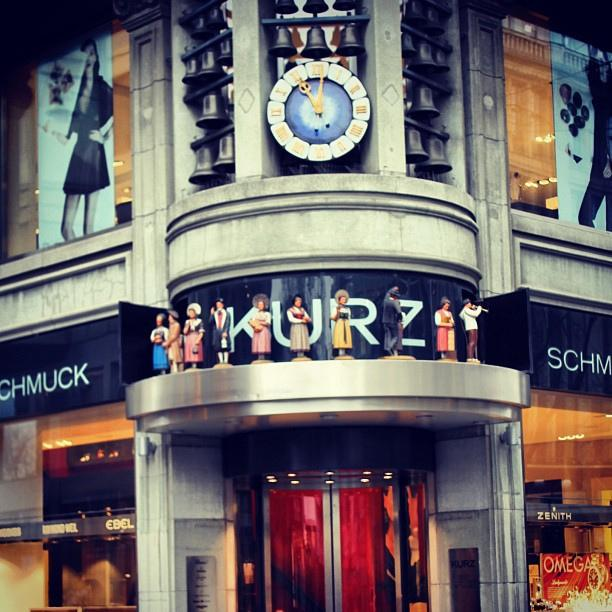What sort of wearable item is available for sale within? Please explain your reasoning. watch. Omega is a timepiece brand 